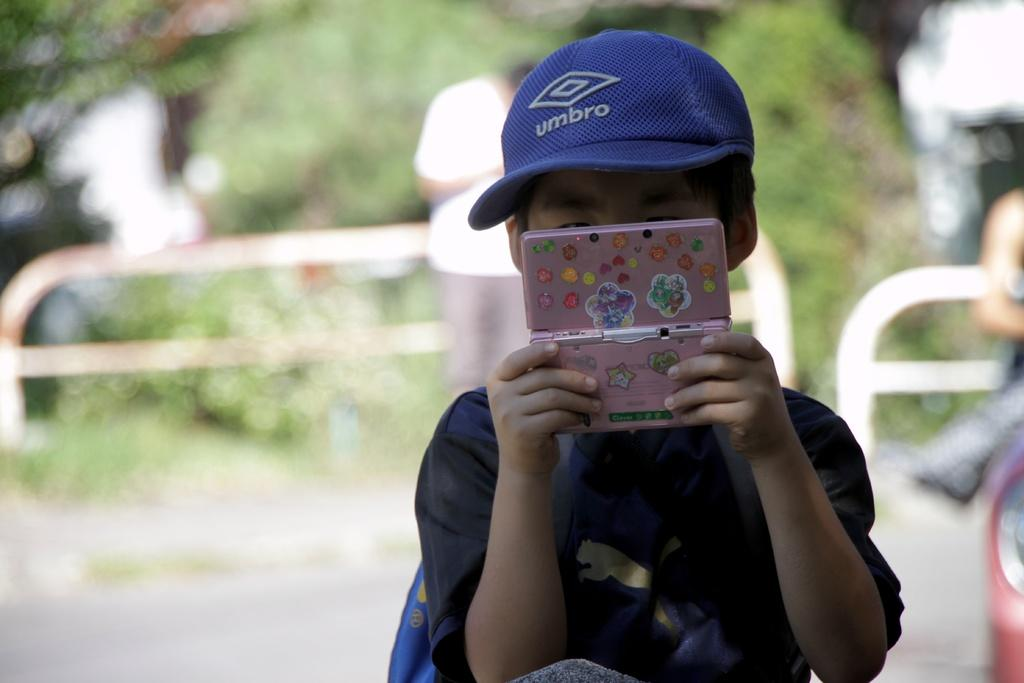Who is the main subject in the image? There is a boy in the image. What is the boy holding in his hand? The boy is holding a pink object in his hand. Can you describe the background of the image? There are people, a fence, a road, and greenery in the background of the image. What type of train can be seen passing by in the image? There is no train present in the image. Is the boy wearing a coat in the image? The image does not show the boy wearing a coat, so it cannot be determined from the image. 